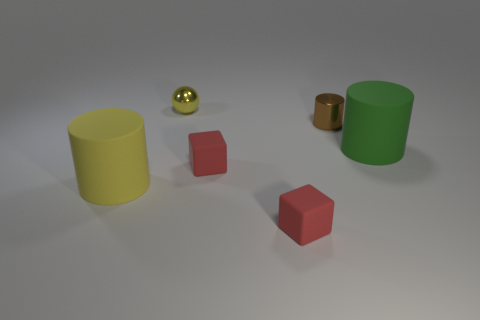Add 2 large yellow metallic things. How many objects exist? 8 Subtract all blocks. How many objects are left? 4 Add 2 tiny cubes. How many tiny cubes are left? 4 Add 5 big yellow rubber cylinders. How many big yellow rubber cylinders exist? 6 Subtract 1 green cylinders. How many objects are left? 5 Subtract all big objects. Subtract all yellow metallic objects. How many objects are left? 3 